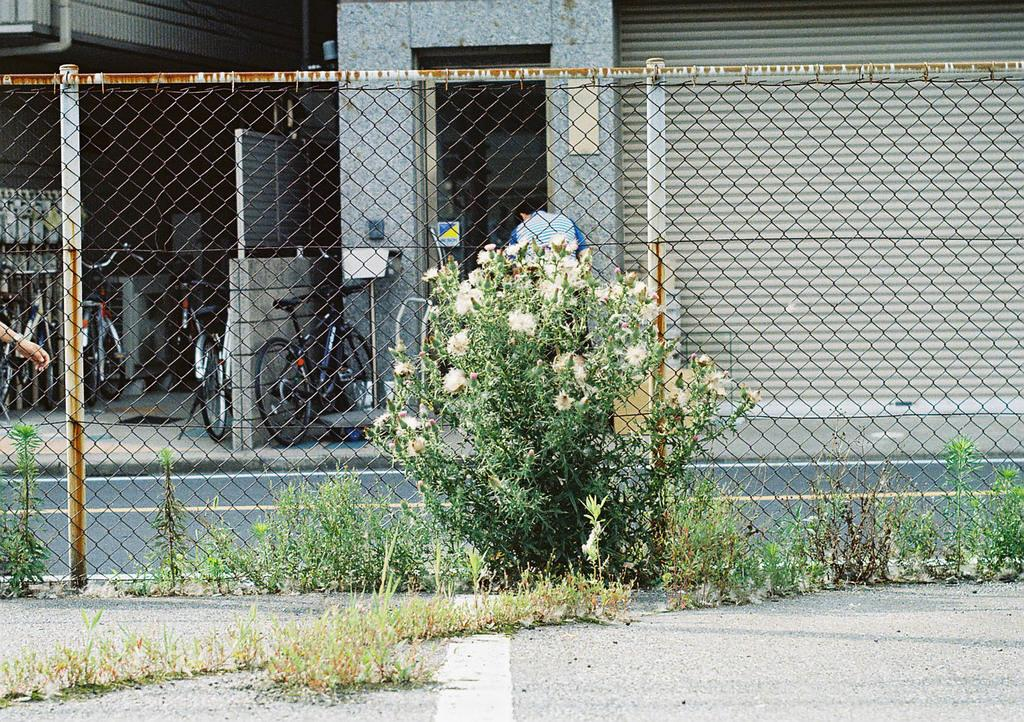What types of vegetation can be seen in the front of the image? There are plants and flowers in the front of the image. What is located in the middle of the image? There is fencing in the middle of the image. What can be seen in the background of the image? There are buildings, bicycles, and a person in the background of the image. What is the purpose of the shutter in the background of the image? The shutter is likely used for controlling light or access to a building or area. What type of pot is being used to cook on the stove in the image? There is no pot or stove present in the image. What boundary is being crossed by the person in the image? There is no boundary being crossed by the person in the image, as the image does not show any specific action or movement by the person. 